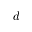<formula> <loc_0><loc_0><loc_500><loc_500>d</formula> 